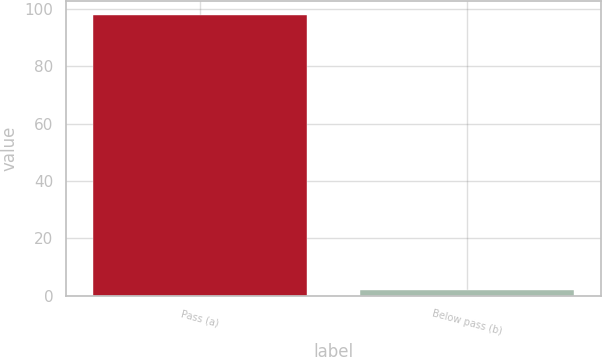Convert chart. <chart><loc_0><loc_0><loc_500><loc_500><bar_chart><fcel>Pass (a)<fcel>Below pass (b)<nl><fcel>98<fcel>2<nl></chart> 